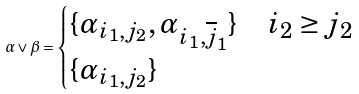<formula> <loc_0><loc_0><loc_500><loc_500>\alpha \vee \beta = \begin{cases} \{ \alpha _ { i _ { 1 } , j _ { 2 } } , \alpha _ { i _ { 1 } , \overline { j } _ { 1 } } \} & i _ { 2 } \geq j _ { 2 } \\ \{ \alpha _ { i _ { 1 } , j _ { 2 } } \} & \end{cases}</formula> 